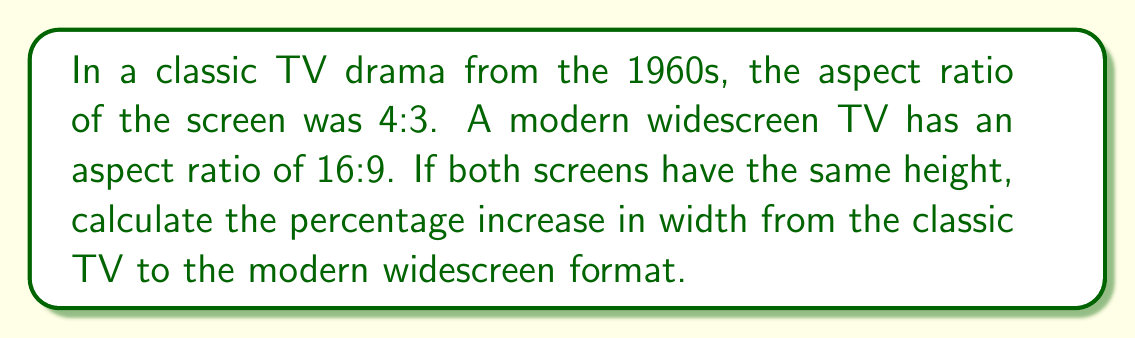Give your solution to this math problem. Let's approach this step-by-step:

1) First, let's define our variables:
   Let $h$ be the height of both screens
   Let $w_c$ be the width of the classic TV
   Let $w_m$ be the width of the modern TV

2) For the classic TV (4:3 ratio):
   $$\frac{w_c}{h} = \frac{4}{3}$$
   $$w_c = \frac{4}{3}h$$

3) For the modern TV (16:9 ratio):
   $$\frac{w_m}{h} = \frac{16}{9}$$
   $$w_m = \frac{16}{9}h$$

4) To find the percentage increase, we use the formula:
   $$\text{Percentage increase} = \frac{\text{Increase}}{\text{Original}} \times 100\%$$
   $$= \frac{w_m - w_c}{w_c} \times 100\%$$

5) Substituting our expressions for $w_m$ and $w_c$:
   $$= \frac{\frac{16}{9}h - \frac{4}{3}h}{\frac{4}{3}h} \times 100\%$$

6) Simplifying:
   $$= \frac{\frac{16}{9} - \frac{4}{3}}{\frac{4}{3}} \times 100\%$$
   $$= \frac{\frac{48}{27} - \frac{36}{27}}{\frac{36}{27}} \times 100\%$$
   $$= \frac{\frac{12}{27}}{\frac{36}{27}} \times 100\%$$
   $$= \frac{1}{3} \times 100\% = 33.33\%$$

Therefore, the width increases by approximately 33.33% from the classic TV to the modern widescreen format.
Answer: 33.33% 